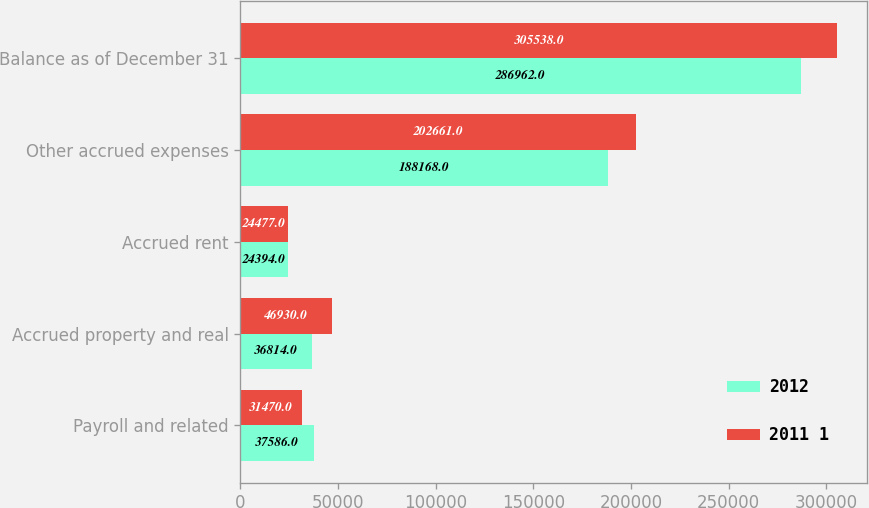<chart> <loc_0><loc_0><loc_500><loc_500><stacked_bar_chart><ecel><fcel>Payroll and related<fcel>Accrued property and real<fcel>Accrued rent<fcel>Other accrued expenses<fcel>Balance as of December 31<nl><fcel>2012<fcel>37586<fcel>36814<fcel>24394<fcel>188168<fcel>286962<nl><fcel>2011 1<fcel>31470<fcel>46930<fcel>24477<fcel>202661<fcel>305538<nl></chart> 